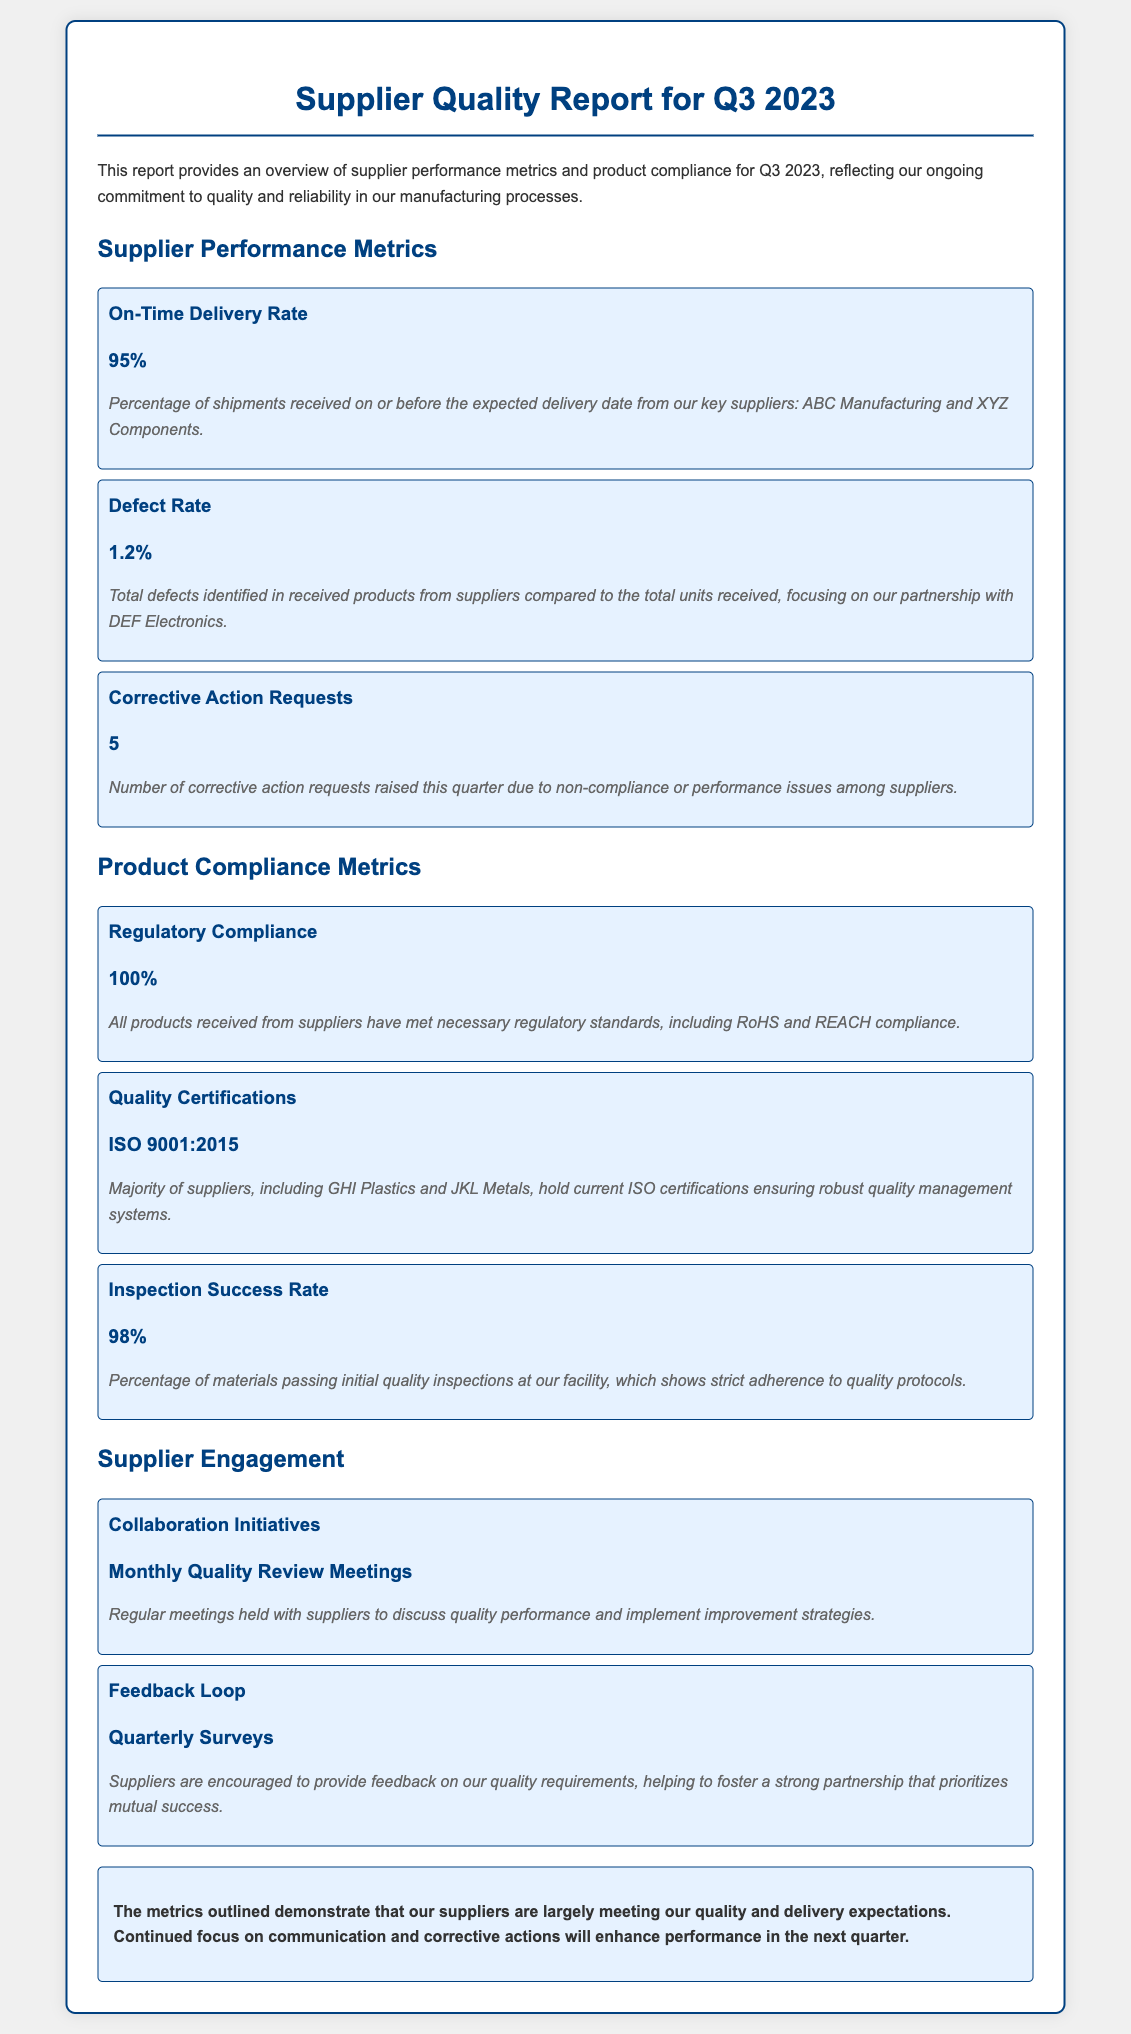what is the On-Time Delivery Rate? The On-Time Delivery Rate is the percentage of shipments received on or before the expected delivery date.
Answer: 95% what is the Defect Rate? The Defect Rate is the total defects identified in received products from suppliers compared to the total units received.
Answer: 1.2% how many Corrective Action Requests were raised? The number of Corrective Action Requests raised due to non-compliance or performance issues among suppliers this quarter.
Answer: 5 what percentage of products met Regulatory Compliance? This refers to the compliance of all products received from suppliers with necessary regulatory standards.
Answer: 100% which ISO certification do the majority of suppliers hold? This is the quality management system standard that most suppliers adhere to, ensuring robust processes.
Answer: ISO 9001:2015 what was the Inspection Success Rate? This indicates the percentage of materials passing initial quality inspections at the facility.
Answer: 98% how often are Collaboration Initiatives held? This refers to the regular meetings aimed at discussing quality performance and improvement strategies with suppliers.
Answer: Monthly what type of feedback mechanism is used with suppliers? This describes the method by which suppliers provide feedback on quality requirements.
Answer: Quarterly Surveys what is the conclusion regarding supplier performance? This provides a summary assessment of supplier metrics related to quality and delivery expectations.
Answer: Suppliers are largely meeting expectations 